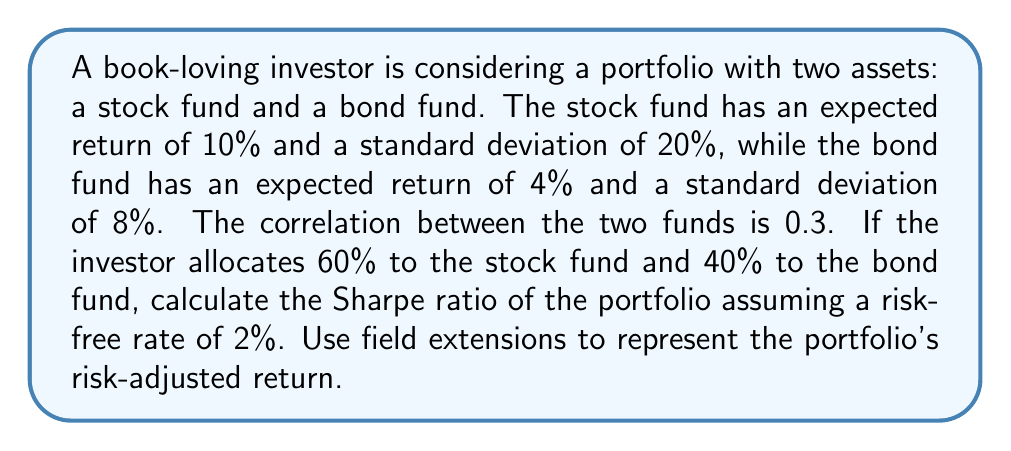Can you solve this math problem? Let's approach this step-by-step using field theory concepts:

1) First, we need to calculate the portfolio's expected return:
   $E(R_p) = w_1E(R_1) + w_2E(R_2)$
   $E(R_p) = 0.6 * 10\% + 0.4 * 4\% = 7.6\%$

2) Next, we calculate the portfolio's variance:
   $\sigma_p^2 = w_1^2\sigma_1^2 + w_2^2\sigma_2^2 + 2w_1w_2\sigma_1\sigma_2\rho_{12}$
   $\sigma_p^2 = 0.6^2 * 0.2^2 + 0.4^2 * 0.08^2 + 2 * 0.6 * 0.4 * 0.2 * 0.08 * 0.3$
   $\sigma_p^2 = 0.0144 + 0.001024 + 0.001152 = 0.016576$

3) Taking the square root to get the portfolio's standard deviation:
   $\sigma_p = \sqrt{0.016576} = 0.1287$ or 12.87%

4) Now, we can calculate the Sharpe ratio:
   $S = \frac{E(R_p) - R_f}{\sigma_p}$
   $S = \frac{7.6\% - 2\%}{12.87\%} = 0.4351$

5) To represent this using field extensions, we can consider the Sharpe ratio as an element of a field extension $K$ over the base field $F$ of real numbers:

   Let $K = F(\alpha)$ where $\alpha$ represents the Sharpe ratio.
   
   The minimal polynomial of $\alpha$ over $F$ would be:
   $p(x) = x - 0.4351$

   This shows that the Sharpe ratio is a simple algebraic extension of the real numbers.

6) The risk-adjusted return can be represented as:
   $R_{adj} = R_f + \alpha\sigma_p$
   $R_{adj} = 2\% + 0.4351 * 12.87\% = 7.6\%$

   This matches our expected portfolio return, confirming our calculations.
Answer: Sharpe ratio: 0.4351 